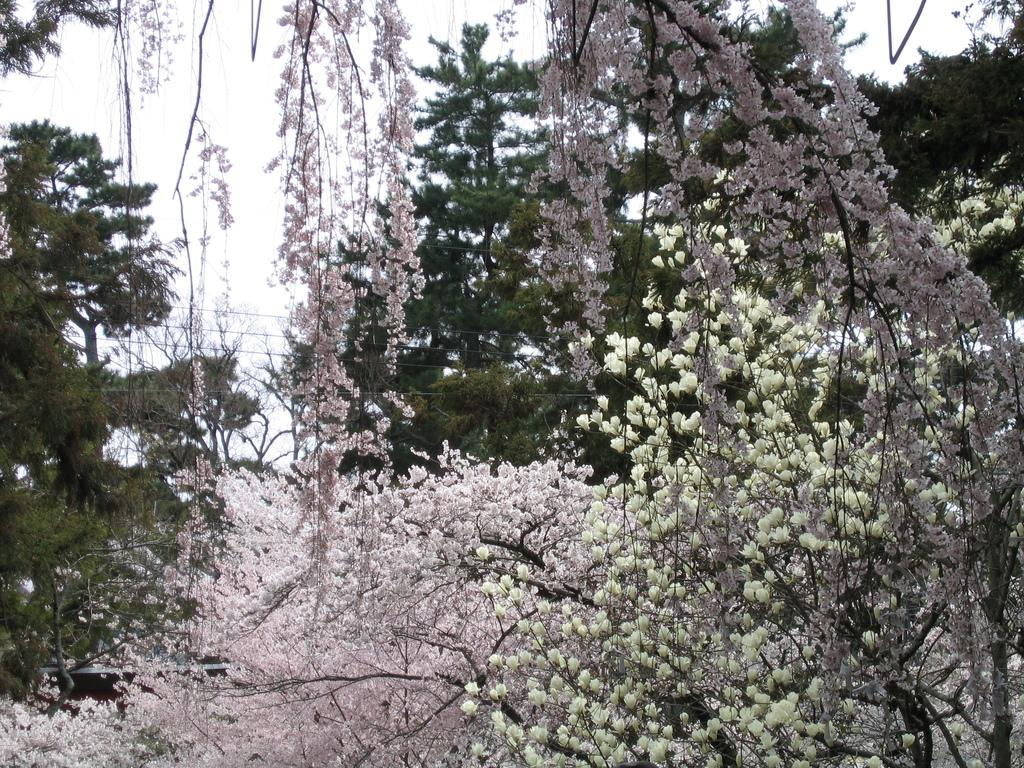What type of vegetation can be seen in the image? There are trees in the image. What colors are the flowers on the trees? The flowers on the trees have pink and white colors. What can be seen in the background of the image? There is a sky visible in the background of the image. Where is the hook located in the image? There is no hook present in the image. What type of pipe can be seen in the image? There is no pipe present in the image. 